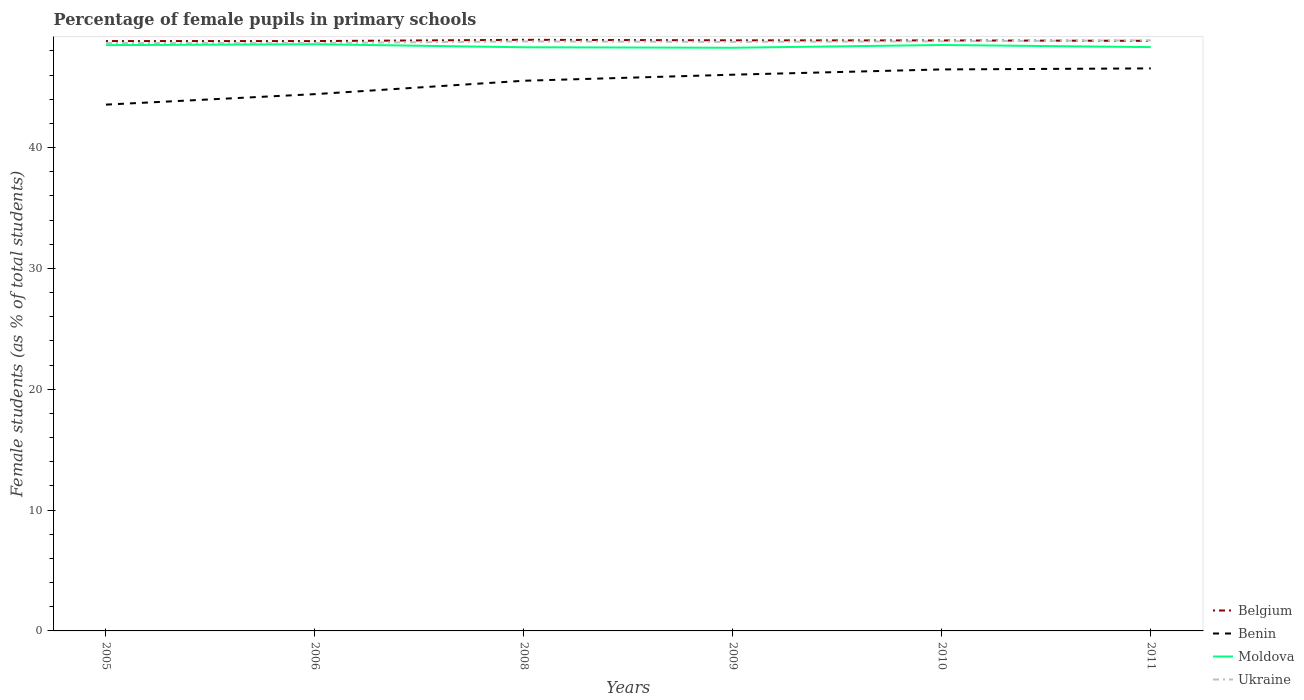Does the line corresponding to Ukraine intersect with the line corresponding to Benin?
Provide a short and direct response. No. Is the number of lines equal to the number of legend labels?
Make the answer very short. Yes. Across all years, what is the maximum percentage of female pupils in primary schools in Ukraine?
Provide a short and direct response. 48.65. In which year was the percentage of female pupils in primary schools in Ukraine maximum?
Offer a very short reply. 2005. What is the total percentage of female pupils in primary schools in Moldova in the graph?
Keep it short and to the point. -0.23. What is the difference between the highest and the second highest percentage of female pupils in primary schools in Moldova?
Offer a terse response. 0.29. What is the difference between the highest and the lowest percentage of female pupils in primary schools in Benin?
Give a very brief answer. 4. Is the percentage of female pupils in primary schools in Ukraine strictly greater than the percentage of female pupils in primary schools in Benin over the years?
Your response must be concise. No. How many lines are there?
Your response must be concise. 4. How many years are there in the graph?
Your response must be concise. 6. Does the graph contain grids?
Provide a succinct answer. No. What is the title of the graph?
Your answer should be very brief. Percentage of female pupils in primary schools. What is the label or title of the Y-axis?
Offer a terse response. Female students (as % of total students). What is the Female students (as % of total students) in Belgium in 2005?
Your answer should be very brief. 48.81. What is the Female students (as % of total students) of Benin in 2005?
Your answer should be compact. 43.55. What is the Female students (as % of total students) in Moldova in 2005?
Make the answer very short. 48.48. What is the Female students (as % of total students) of Ukraine in 2005?
Your answer should be compact. 48.65. What is the Female students (as % of total students) of Belgium in 2006?
Your answer should be very brief. 48.81. What is the Female students (as % of total students) in Benin in 2006?
Your answer should be compact. 44.42. What is the Female students (as % of total students) in Moldova in 2006?
Ensure brevity in your answer.  48.55. What is the Female students (as % of total students) of Ukraine in 2006?
Your answer should be compact. 48.65. What is the Female students (as % of total students) in Belgium in 2008?
Provide a succinct answer. 48.92. What is the Female students (as % of total students) of Benin in 2008?
Your answer should be very brief. 45.53. What is the Female students (as % of total students) of Moldova in 2008?
Keep it short and to the point. 48.3. What is the Female students (as % of total students) of Ukraine in 2008?
Keep it short and to the point. 48.79. What is the Female students (as % of total students) in Belgium in 2009?
Provide a succinct answer. 48.87. What is the Female students (as % of total students) of Benin in 2009?
Make the answer very short. 46.03. What is the Female students (as % of total students) of Moldova in 2009?
Provide a succinct answer. 48.26. What is the Female students (as % of total students) in Ukraine in 2009?
Keep it short and to the point. 48.75. What is the Female students (as % of total students) in Belgium in 2010?
Your answer should be compact. 48.86. What is the Female students (as % of total students) in Benin in 2010?
Provide a short and direct response. 46.47. What is the Female students (as % of total students) in Moldova in 2010?
Your response must be concise. 48.49. What is the Female students (as % of total students) of Ukraine in 2010?
Provide a succinct answer. 48.8. What is the Female students (as % of total students) of Belgium in 2011?
Offer a very short reply. 48.83. What is the Female students (as % of total students) of Benin in 2011?
Give a very brief answer. 46.55. What is the Female students (as % of total students) of Moldova in 2011?
Offer a terse response. 48.31. What is the Female students (as % of total students) in Ukraine in 2011?
Ensure brevity in your answer.  48.87. Across all years, what is the maximum Female students (as % of total students) in Belgium?
Make the answer very short. 48.92. Across all years, what is the maximum Female students (as % of total students) in Benin?
Offer a very short reply. 46.55. Across all years, what is the maximum Female students (as % of total students) of Moldova?
Offer a terse response. 48.55. Across all years, what is the maximum Female students (as % of total students) in Ukraine?
Give a very brief answer. 48.87. Across all years, what is the minimum Female students (as % of total students) of Belgium?
Your answer should be compact. 48.81. Across all years, what is the minimum Female students (as % of total students) in Benin?
Your answer should be compact. 43.55. Across all years, what is the minimum Female students (as % of total students) of Moldova?
Keep it short and to the point. 48.26. Across all years, what is the minimum Female students (as % of total students) in Ukraine?
Provide a short and direct response. 48.65. What is the total Female students (as % of total students) in Belgium in the graph?
Provide a succinct answer. 293.11. What is the total Female students (as % of total students) in Benin in the graph?
Provide a short and direct response. 272.55. What is the total Female students (as % of total students) of Moldova in the graph?
Give a very brief answer. 290.39. What is the total Female students (as % of total students) in Ukraine in the graph?
Make the answer very short. 292.5. What is the difference between the Female students (as % of total students) in Belgium in 2005 and that in 2006?
Your response must be concise. 0. What is the difference between the Female students (as % of total students) in Benin in 2005 and that in 2006?
Your answer should be compact. -0.87. What is the difference between the Female students (as % of total students) in Moldova in 2005 and that in 2006?
Offer a terse response. -0.08. What is the difference between the Female students (as % of total students) of Ukraine in 2005 and that in 2006?
Offer a terse response. -0. What is the difference between the Female students (as % of total students) in Belgium in 2005 and that in 2008?
Offer a terse response. -0.1. What is the difference between the Female students (as % of total students) in Benin in 2005 and that in 2008?
Provide a short and direct response. -1.98. What is the difference between the Female students (as % of total students) in Moldova in 2005 and that in 2008?
Provide a short and direct response. 0.18. What is the difference between the Female students (as % of total students) of Ukraine in 2005 and that in 2008?
Provide a succinct answer. -0.14. What is the difference between the Female students (as % of total students) in Belgium in 2005 and that in 2009?
Give a very brief answer. -0.06. What is the difference between the Female students (as % of total students) of Benin in 2005 and that in 2009?
Your response must be concise. -2.48. What is the difference between the Female students (as % of total students) in Moldova in 2005 and that in 2009?
Provide a short and direct response. 0.22. What is the difference between the Female students (as % of total students) of Ukraine in 2005 and that in 2009?
Your response must be concise. -0.1. What is the difference between the Female students (as % of total students) in Belgium in 2005 and that in 2010?
Offer a very short reply. -0.05. What is the difference between the Female students (as % of total students) in Benin in 2005 and that in 2010?
Offer a terse response. -2.91. What is the difference between the Female students (as % of total students) in Moldova in 2005 and that in 2010?
Provide a short and direct response. -0.01. What is the difference between the Female students (as % of total students) of Ukraine in 2005 and that in 2010?
Provide a short and direct response. -0.15. What is the difference between the Female students (as % of total students) in Belgium in 2005 and that in 2011?
Your answer should be very brief. -0.02. What is the difference between the Female students (as % of total students) of Benin in 2005 and that in 2011?
Offer a very short reply. -3. What is the difference between the Female students (as % of total students) of Moldova in 2005 and that in 2011?
Keep it short and to the point. 0.16. What is the difference between the Female students (as % of total students) of Ukraine in 2005 and that in 2011?
Give a very brief answer. -0.22. What is the difference between the Female students (as % of total students) in Belgium in 2006 and that in 2008?
Provide a short and direct response. -0.1. What is the difference between the Female students (as % of total students) of Benin in 2006 and that in 2008?
Offer a very short reply. -1.11. What is the difference between the Female students (as % of total students) in Moldova in 2006 and that in 2008?
Provide a succinct answer. 0.25. What is the difference between the Female students (as % of total students) in Ukraine in 2006 and that in 2008?
Provide a short and direct response. -0.14. What is the difference between the Female students (as % of total students) of Belgium in 2006 and that in 2009?
Your response must be concise. -0.06. What is the difference between the Female students (as % of total students) in Benin in 2006 and that in 2009?
Your answer should be compact. -1.61. What is the difference between the Female students (as % of total students) in Moldova in 2006 and that in 2009?
Provide a short and direct response. 0.29. What is the difference between the Female students (as % of total students) in Ukraine in 2006 and that in 2009?
Provide a short and direct response. -0.1. What is the difference between the Female students (as % of total students) in Belgium in 2006 and that in 2010?
Your answer should be compact. -0.05. What is the difference between the Female students (as % of total students) of Benin in 2006 and that in 2010?
Your answer should be compact. -2.05. What is the difference between the Female students (as % of total students) in Moldova in 2006 and that in 2010?
Provide a short and direct response. 0.06. What is the difference between the Female students (as % of total students) of Ukraine in 2006 and that in 2010?
Your answer should be compact. -0.15. What is the difference between the Female students (as % of total students) of Belgium in 2006 and that in 2011?
Ensure brevity in your answer.  -0.02. What is the difference between the Female students (as % of total students) in Benin in 2006 and that in 2011?
Ensure brevity in your answer.  -2.13. What is the difference between the Female students (as % of total students) of Moldova in 2006 and that in 2011?
Your answer should be very brief. 0.24. What is the difference between the Female students (as % of total students) of Ukraine in 2006 and that in 2011?
Give a very brief answer. -0.22. What is the difference between the Female students (as % of total students) of Belgium in 2008 and that in 2009?
Your answer should be very brief. 0.04. What is the difference between the Female students (as % of total students) of Benin in 2008 and that in 2009?
Ensure brevity in your answer.  -0.5. What is the difference between the Female students (as % of total students) in Moldova in 2008 and that in 2009?
Offer a very short reply. 0.04. What is the difference between the Female students (as % of total students) of Ukraine in 2008 and that in 2009?
Offer a terse response. 0.04. What is the difference between the Female students (as % of total students) in Belgium in 2008 and that in 2010?
Make the answer very short. 0.05. What is the difference between the Female students (as % of total students) in Benin in 2008 and that in 2010?
Ensure brevity in your answer.  -0.94. What is the difference between the Female students (as % of total students) of Moldova in 2008 and that in 2010?
Offer a very short reply. -0.19. What is the difference between the Female students (as % of total students) of Ukraine in 2008 and that in 2010?
Ensure brevity in your answer.  -0.01. What is the difference between the Female students (as % of total students) of Belgium in 2008 and that in 2011?
Offer a terse response. 0.08. What is the difference between the Female students (as % of total students) in Benin in 2008 and that in 2011?
Provide a short and direct response. -1.02. What is the difference between the Female students (as % of total students) in Moldova in 2008 and that in 2011?
Your answer should be compact. -0.01. What is the difference between the Female students (as % of total students) in Ukraine in 2008 and that in 2011?
Your answer should be very brief. -0.09. What is the difference between the Female students (as % of total students) of Belgium in 2009 and that in 2010?
Offer a very short reply. 0.01. What is the difference between the Female students (as % of total students) in Benin in 2009 and that in 2010?
Offer a terse response. -0.44. What is the difference between the Female students (as % of total students) in Moldova in 2009 and that in 2010?
Offer a terse response. -0.23. What is the difference between the Female students (as % of total students) in Ukraine in 2009 and that in 2010?
Provide a short and direct response. -0.05. What is the difference between the Female students (as % of total students) of Belgium in 2009 and that in 2011?
Offer a very short reply. 0.04. What is the difference between the Female students (as % of total students) of Benin in 2009 and that in 2011?
Give a very brief answer. -0.52. What is the difference between the Female students (as % of total students) in Moldova in 2009 and that in 2011?
Your answer should be compact. -0.05. What is the difference between the Female students (as % of total students) in Ukraine in 2009 and that in 2011?
Offer a terse response. -0.13. What is the difference between the Female students (as % of total students) in Belgium in 2010 and that in 2011?
Provide a short and direct response. 0.03. What is the difference between the Female students (as % of total students) in Benin in 2010 and that in 2011?
Give a very brief answer. -0.08. What is the difference between the Female students (as % of total students) of Moldova in 2010 and that in 2011?
Give a very brief answer. 0.17. What is the difference between the Female students (as % of total students) in Ukraine in 2010 and that in 2011?
Your response must be concise. -0.08. What is the difference between the Female students (as % of total students) in Belgium in 2005 and the Female students (as % of total students) in Benin in 2006?
Offer a terse response. 4.39. What is the difference between the Female students (as % of total students) of Belgium in 2005 and the Female students (as % of total students) of Moldova in 2006?
Provide a short and direct response. 0.26. What is the difference between the Female students (as % of total students) in Belgium in 2005 and the Female students (as % of total students) in Ukraine in 2006?
Offer a very short reply. 0.17. What is the difference between the Female students (as % of total students) in Benin in 2005 and the Female students (as % of total students) in Moldova in 2006?
Give a very brief answer. -5. What is the difference between the Female students (as % of total students) of Benin in 2005 and the Female students (as % of total students) of Ukraine in 2006?
Ensure brevity in your answer.  -5.1. What is the difference between the Female students (as % of total students) of Moldova in 2005 and the Female students (as % of total students) of Ukraine in 2006?
Your answer should be very brief. -0.17. What is the difference between the Female students (as % of total students) in Belgium in 2005 and the Female students (as % of total students) in Benin in 2008?
Ensure brevity in your answer.  3.29. What is the difference between the Female students (as % of total students) of Belgium in 2005 and the Female students (as % of total students) of Moldova in 2008?
Your answer should be compact. 0.52. What is the difference between the Female students (as % of total students) in Belgium in 2005 and the Female students (as % of total students) in Ukraine in 2008?
Your answer should be compact. 0.03. What is the difference between the Female students (as % of total students) in Benin in 2005 and the Female students (as % of total students) in Moldova in 2008?
Your answer should be compact. -4.74. What is the difference between the Female students (as % of total students) in Benin in 2005 and the Female students (as % of total students) in Ukraine in 2008?
Your response must be concise. -5.23. What is the difference between the Female students (as % of total students) of Moldova in 2005 and the Female students (as % of total students) of Ukraine in 2008?
Your response must be concise. -0.31. What is the difference between the Female students (as % of total students) in Belgium in 2005 and the Female students (as % of total students) in Benin in 2009?
Make the answer very short. 2.79. What is the difference between the Female students (as % of total students) of Belgium in 2005 and the Female students (as % of total students) of Moldova in 2009?
Your response must be concise. 0.55. What is the difference between the Female students (as % of total students) of Belgium in 2005 and the Female students (as % of total students) of Ukraine in 2009?
Ensure brevity in your answer.  0.07. What is the difference between the Female students (as % of total students) of Benin in 2005 and the Female students (as % of total students) of Moldova in 2009?
Offer a very short reply. -4.71. What is the difference between the Female students (as % of total students) in Benin in 2005 and the Female students (as % of total students) in Ukraine in 2009?
Keep it short and to the point. -5.19. What is the difference between the Female students (as % of total students) in Moldova in 2005 and the Female students (as % of total students) in Ukraine in 2009?
Give a very brief answer. -0.27. What is the difference between the Female students (as % of total students) in Belgium in 2005 and the Female students (as % of total students) in Benin in 2010?
Your answer should be very brief. 2.35. What is the difference between the Female students (as % of total students) in Belgium in 2005 and the Female students (as % of total students) in Moldova in 2010?
Ensure brevity in your answer.  0.33. What is the difference between the Female students (as % of total students) of Belgium in 2005 and the Female students (as % of total students) of Ukraine in 2010?
Your response must be concise. 0.02. What is the difference between the Female students (as % of total students) of Benin in 2005 and the Female students (as % of total students) of Moldova in 2010?
Ensure brevity in your answer.  -4.93. What is the difference between the Female students (as % of total students) of Benin in 2005 and the Female students (as % of total students) of Ukraine in 2010?
Offer a terse response. -5.24. What is the difference between the Female students (as % of total students) of Moldova in 2005 and the Female students (as % of total students) of Ukraine in 2010?
Give a very brief answer. -0.32. What is the difference between the Female students (as % of total students) of Belgium in 2005 and the Female students (as % of total students) of Benin in 2011?
Make the answer very short. 2.26. What is the difference between the Female students (as % of total students) of Belgium in 2005 and the Female students (as % of total students) of Moldova in 2011?
Your response must be concise. 0.5. What is the difference between the Female students (as % of total students) of Belgium in 2005 and the Female students (as % of total students) of Ukraine in 2011?
Your answer should be very brief. -0.06. What is the difference between the Female students (as % of total students) of Benin in 2005 and the Female students (as % of total students) of Moldova in 2011?
Provide a succinct answer. -4.76. What is the difference between the Female students (as % of total students) in Benin in 2005 and the Female students (as % of total students) in Ukraine in 2011?
Give a very brief answer. -5.32. What is the difference between the Female students (as % of total students) of Moldova in 2005 and the Female students (as % of total students) of Ukraine in 2011?
Your response must be concise. -0.4. What is the difference between the Female students (as % of total students) of Belgium in 2006 and the Female students (as % of total students) of Benin in 2008?
Offer a terse response. 3.28. What is the difference between the Female students (as % of total students) in Belgium in 2006 and the Female students (as % of total students) in Moldova in 2008?
Make the answer very short. 0.51. What is the difference between the Female students (as % of total students) of Belgium in 2006 and the Female students (as % of total students) of Ukraine in 2008?
Provide a short and direct response. 0.03. What is the difference between the Female students (as % of total students) in Benin in 2006 and the Female students (as % of total students) in Moldova in 2008?
Offer a very short reply. -3.88. What is the difference between the Female students (as % of total students) of Benin in 2006 and the Female students (as % of total students) of Ukraine in 2008?
Provide a short and direct response. -4.36. What is the difference between the Female students (as % of total students) in Moldova in 2006 and the Female students (as % of total students) in Ukraine in 2008?
Keep it short and to the point. -0.23. What is the difference between the Female students (as % of total students) in Belgium in 2006 and the Female students (as % of total students) in Benin in 2009?
Ensure brevity in your answer.  2.78. What is the difference between the Female students (as % of total students) of Belgium in 2006 and the Female students (as % of total students) of Moldova in 2009?
Ensure brevity in your answer.  0.55. What is the difference between the Female students (as % of total students) of Belgium in 2006 and the Female students (as % of total students) of Ukraine in 2009?
Provide a short and direct response. 0.07. What is the difference between the Female students (as % of total students) in Benin in 2006 and the Female students (as % of total students) in Moldova in 2009?
Your answer should be very brief. -3.84. What is the difference between the Female students (as % of total students) in Benin in 2006 and the Female students (as % of total students) in Ukraine in 2009?
Keep it short and to the point. -4.33. What is the difference between the Female students (as % of total students) of Moldova in 2006 and the Female students (as % of total students) of Ukraine in 2009?
Ensure brevity in your answer.  -0.19. What is the difference between the Female students (as % of total students) in Belgium in 2006 and the Female students (as % of total students) in Benin in 2010?
Your answer should be compact. 2.35. What is the difference between the Female students (as % of total students) in Belgium in 2006 and the Female students (as % of total students) in Moldova in 2010?
Keep it short and to the point. 0.32. What is the difference between the Female students (as % of total students) of Belgium in 2006 and the Female students (as % of total students) of Ukraine in 2010?
Make the answer very short. 0.02. What is the difference between the Female students (as % of total students) of Benin in 2006 and the Female students (as % of total students) of Moldova in 2010?
Keep it short and to the point. -4.07. What is the difference between the Female students (as % of total students) in Benin in 2006 and the Female students (as % of total students) in Ukraine in 2010?
Your answer should be very brief. -4.37. What is the difference between the Female students (as % of total students) in Moldova in 2006 and the Female students (as % of total students) in Ukraine in 2010?
Your response must be concise. -0.24. What is the difference between the Female students (as % of total students) of Belgium in 2006 and the Female students (as % of total students) of Benin in 2011?
Provide a short and direct response. 2.26. What is the difference between the Female students (as % of total students) in Belgium in 2006 and the Female students (as % of total students) in Moldova in 2011?
Offer a very short reply. 0.5. What is the difference between the Female students (as % of total students) of Belgium in 2006 and the Female students (as % of total students) of Ukraine in 2011?
Offer a terse response. -0.06. What is the difference between the Female students (as % of total students) of Benin in 2006 and the Female students (as % of total students) of Moldova in 2011?
Make the answer very short. -3.89. What is the difference between the Female students (as % of total students) in Benin in 2006 and the Female students (as % of total students) in Ukraine in 2011?
Ensure brevity in your answer.  -4.45. What is the difference between the Female students (as % of total students) in Moldova in 2006 and the Female students (as % of total students) in Ukraine in 2011?
Make the answer very short. -0.32. What is the difference between the Female students (as % of total students) in Belgium in 2008 and the Female students (as % of total students) in Benin in 2009?
Give a very brief answer. 2.89. What is the difference between the Female students (as % of total students) of Belgium in 2008 and the Female students (as % of total students) of Moldova in 2009?
Your answer should be compact. 0.66. What is the difference between the Female students (as % of total students) in Belgium in 2008 and the Female students (as % of total students) in Ukraine in 2009?
Make the answer very short. 0.17. What is the difference between the Female students (as % of total students) of Benin in 2008 and the Female students (as % of total students) of Moldova in 2009?
Your answer should be very brief. -2.73. What is the difference between the Female students (as % of total students) in Benin in 2008 and the Female students (as % of total students) in Ukraine in 2009?
Your response must be concise. -3.22. What is the difference between the Female students (as % of total students) of Moldova in 2008 and the Female students (as % of total students) of Ukraine in 2009?
Ensure brevity in your answer.  -0.45. What is the difference between the Female students (as % of total students) in Belgium in 2008 and the Female students (as % of total students) in Benin in 2010?
Provide a short and direct response. 2.45. What is the difference between the Female students (as % of total students) of Belgium in 2008 and the Female students (as % of total students) of Moldova in 2010?
Keep it short and to the point. 0.43. What is the difference between the Female students (as % of total students) of Belgium in 2008 and the Female students (as % of total students) of Ukraine in 2010?
Give a very brief answer. 0.12. What is the difference between the Female students (as % of total students) in Benin in 2008 and the Female students (as % of total students) in Moldova in 2010?
Your answer should be compact. -2.96. What is the difference between the Female students (as % of total students) in Benin in 2008 and the Female students (as % of total students) in Ukraine in 2010?
Provide a short and direct response. -3.27. What is the difference between the Female students (as % of total students) in Moldova in 2008 and the Female students (as % of total students) in Ukraine in 2010?
Offer a terse response. -0.5. What is the difference between the Female students (as % of total students) of Belgium in 2008 and the Female students (as % of total students) of Benin in 2011?
Keep it short and to the point. 2.37. What is the difference between the Female students (as % of total students) in Belgium in 2008 and the Female students (as % of total students) in Moldova in 2011?
Keep it short and to the point. 0.6. What is the difference between the Female students (as % of total students) in Belgium in 2008 and the Female students (as % of total students) in Ukraine in 2011?
Offer a terse response. 0.04. What is the difference between the Female students (as % of total students) of Benin in 2008 and the Female students (as % of total students) of Moldova in 2011?
Your answer should be very brief. -2.78. What is the difference between the Female students (as % of total students) in Benin in 2008 and the Female students (as % of total students) in Ukraine in 2011?
Your answer should be compact. -3.34. What is the difference between the Female students (as % of total students) of Moldova in 2008 and the Female students (as % of total students) of Ukraine in 2011?
Provide a short and direct response. -0.57. What is the difference between the Female students (as % of total students) of Belgium in 2009 and the Female students (as % of total students) of Benin in 2010?
Make the answer very short. 2.41. What is the difference between the Female students (as % of total students) in Belgium in 2009 and the Female students (as % of total students) in Moldova in 2010?
Provide a succinct answer. 0.39. What is the difference between the Female students (as % of total students) of Belgium in 2009 and the Female students (as % of total students) of Ukraine in 2010?
Make the answer very short. 0.08. What is the difference between the Female students (as % of total students) in Benin in 2009 and the Female students (as % of total students) in Moldova in 2010?
Ensure brevity in your answer.  -2.46. What is the difference between the Female students (as % of total students) in Benin in 2009 and the Female students (as % of total students) in Ukraine in 2010?
Provide a succinct answer. -2.77. What is the difference between the Female students (as % of total students) in Moldova in 2009 and the Female students (as % of total students) in Ukraine in 2010?
Your answer should be compact. -0.54. What is the difference between the Female students (as % of total students) of Belgium in 2009 and the Female students (as % of total students) of Benin in 2011?
Your answer should be compact. 2.32. What is the difference between the Female students (as % of total students) in Belgium in 2009 and the Female students (as % of total students) in Moldova in 2011?
Provide a succinct answer. 0.56. What is the difference between the Female students (as % of total students) of Belgium in 2009 and the Female students (as % of total students) of Ukraine in 2011?
Provide a short and direct response. 0. What is the difference between the Female students (as % of total students) of Benin in 2009 and the Female students (as % of total students) of Moldova in 2011?
Make the answer very short. -2.28. What is the difference between the Female students (as % of total students) of Benin in 2009 and the Female students (as % of total students) of Ukraine in 2011?
Your response must be concise. -2.84. What is the difference between the Female students (as % of total students) of Moldova in 2009 and the Female students (as % of total students) of Ukraine in 2011?
Offer a terse response. -0.61. What is the difference between the Female students (as % of total students) in Belgium in 2010 and the Female students (as % of total students) in Benin in 2011?
Your answer should be compact. 2.31. What is the difference between the Female students (as % of total students) of Belgium in 2010 and the Female students (as % of total students) of Moldova in 2011?
Keep it short and to the point. 0.55. What is the difference between the Female students (as % of total students) of Belgium in 2010 and the Female students (as % of total students) of Ukraine in 2011?
Ensure brevity in your answer.  -0.01. What is the difference between the Female students (as % of total students) of Benin in 2010 and the Female students (as % of total students) of Moldova in 2011?
Provide a succinct answer. -1.85. What is the difference between the Female students (as % of total students) in Benin in 2010 and the Female students (as % of total students) in Ukraine in 2011?
Give a very brief answer. -2.41. What is the difference between the Female students (as % of total students) of Moldova in 2010 and the Female students (as % of total students) of Ukraine in 2011?
Offer a terse response. -0.38. What is the average Female students (as % of total students) of Belgium per year?
Your answer should be compact. 48.85. What is the average Female students (as % of total students) of Benin per year?
Offer a very short reply. 45.42. What is the average Female students (as % of total students) of Moldova per year?
Make the answer very short. 48.4. What is the average Female students (as % of total students) in Ukraine per year?
Keep it short and to the point. 48.75. In the year 2005, what is the difference between the Female students (as % of total students) in Belgium and Female students (as % of total students) in Benin?
Ensure brevity in your answer.  5.26. In the year 2005, what is the difference between the Female students (as % of total students) in Belgium and Female students (as % of total students) in Moldova?
Keep it short and to the point. 0.34. In the year 2005, what is the difference between the Female students (as % of total students) of Belgium and Female students (as % of total students) of Ukraine?
Offer a terse response. 0.17. In the year 2005, what is the difference between the Female students (as % of total students) of Benin and Female students (as % of total students) of Moldova?
Your response must be concise. -4.92. In the year 2005, what is the difference between the Female students (as % of total students) of Benin and Female students (as % of total students) of Ukraine?
Ensure brevity in your answer.  -5.09. In the year 2005, what is the difference between the Female students (as % of total students) in Moldova and Female students (as % of total students) in Ukraine?
Give a very brief answer. -0.17. In the year 2006, what is the difference between the Female students (as % of total students) in Belgium and Female students (as % of total students) in Benin?
Offer a terse response. 4.39. In the year 2006, what is the difference between the Female students (as % of total students) in Belgium and Female students (as % of total students) in Moldova?
Offer a terse response. 0.26. In the year 2006, what is the difference between the Female students (as % of total students) in Belgium and Female students (as % of total students) in Ukraine?
Provide a succinct answer. 0.16. In the year 2006, what is the difference between the Female students (as % of total students) in Benin and Female students (as % of total students) in Moldova?
Provide a succinct answer. -4.13. In the year 2006, what is the difference between the Female students (as % of total students) in Benin and Female students (as % of total students) in Ukraine?
Offer a very short reply. -4.23. In the year 2006, what is the difference between the Female students (as % of total students) in Moldova and Female students (as % of total students) in Ukraine?
Provide a short and direct response. -0.1. In the year 2008, what is the difference between the Female students (as % of total students) in Belgium and Female students (as % of total students) in Benin?
Offer a terse response. 3.39. In the year 2008, what is the difference between the Female students (as % of total students) in Belgium and Female students (as % of total students) in Moldova?
Your answer should be compact. 0.62. In the year 2008, what is the difference between the Female students (as % of total students) of Belgium and Female students (as % of total students) of Ukraine?
Provide a succinct answer. 0.13. In the year 2008, what is the difference between the Female students (as % of total students) in Benin and Female students (as % of total students) in Moldova?
Give a very brief answer. -2.77. In the year 2008, what is the difference between the Female students (as % of total students) of Benin and Female students (as % of total students) of Ukraine?
Provide a short and direct response. -3.26. In the year 2008, what is the difference between the Female students (as % of total students) of Moldova and Female students (as % of total students) of Ukraine?
Keep it short and to the point. -0.49. In the year 2009, what is the difference between the Female students (as % of total students) of Belgium and Female students (as % of total students) of Benin?
Ensure brevity in your answer.  2.84. In the year 2009, what is the difference between the Female students (as % of total students) in Belgium and Female students (as % of total students) in Moldova?
Give a very brief answer. 0.61. In the year 2009, what is the difference between the Female students (as % of total students) of Belgium and Female students (as % of total students) of Ukraine?
Ensure brevity in your answer.  0.13. In the year 2009, what is the difference between the Female students (as % of total students) of Benin and Female students (as % of total students) of Moldova?
Ensure brevity in your answer.  -2.23. In the year 2009, what is the difference between the Female students (as % of total students) of Benin and Female students (as % of total students) of Ukraine?
Provide a short and direct response. -2.72. In the year 2009, what is the difference between the Female students (as % of total students) in Moldova and Female students (as % of total students) in Ukraine?
Offer a terse response. -0.49. In the year 2010, what is the difference between the Female students (as % of total students) of Belgium and Female students (as % of total students) of Benin?
Provide a short and direct response. 2.4. In the year 2010, what is the difference between the Female students (as % of total students) in Belgium and Female students (as % of total students) in Moldova?
Make the answer very short. 0.38. In the year 2010, what is the difference between the Female students (as % of total students) in Belgium and Female students (as % of total students) in Ukraine?
Make the answer very short. 0.07. In the year 2010, what is the difference between the Female students (as % of total students) in Benin and Female students (as % of total students) in Moldova?
Provide a short and direct response. -2.02. In the year 2010, what is the difference between the Female students (as % of total students) in Benin and Female students (as % of total students) in Ukraine?
Give a very brief answer. -2.33. In the year 2010, what is the difference between the Female students (as % of total students) of Moldova and Female students (as % of total students) of Ukraine?
Ensure brevity in your answer.  -0.31. In the year 2011, what is the difference between the Female students (as % of total students) of Belgium and Female students (as % of total students) of Benin?
Offer a terse response. 2.28. In the year 2011, what is the difference between the Female students (as % of total students) of Belgium and Female students (as % of total students) of Moldova?
Provide a succinct answer. 0.52. In the year 2011, what is the difference between the Female students (as % of total students) of Belgium and Female students (as % of total students) of Ukraine?
Keep it short and to the point. -0.04. In the year 2011, what is the difference between the Female students (as % of total students) in Benin and Female students (as % of total students) in Moldova?
Offer a very short reply. -1.76. In the year 2011, what is the difference between the Female students (as % of total students) in Benin and Female students (as % of total students) in Ukraine?
Keep it short and to the point. -2.32. In the year 2011, what is the difference between the Female students (as % of total students) of Moldova and Female students (as % of total students) of Ukraine?
Ensure brevity in your answer.  -0.56. What is the ratio of the Female students (as % of total students) in Belgium in 2005 to that in 2006?
Your answer should be very brief. 1. What is the ratio of the Female students (as % of total students) in Benin in 2005 to that in 2006?
Provide a short and direct response. 0.98. What is the ratio of the Female students (as % of total students) of Moldova in 2005 to that in 2006?
Your response must be concise. 1. What is the ratio of the Female students (as % of total students) in Benin in 2005 to that in 2008?
Make the answer very short. 0.96. What is the ratio of the Female students (as % of total students) in Moldova in 2005 to that in 2008?
Your answer should be compact. 1. What is the ratio of the Female students (as % of total students) in Benin in 2005 to that in 2009?
Offer a very short reply. 0.95. What is the ratio of the Female students (as % of total students) of Moldova in 2005 to that in 2009?
Offer a very short reply. 1. What is the ratio of the Female students (as % of total students) of Ukraine in 2005 to that in 2009?
Your response must be concise. 1. What is the ratio of the Female students (as % of total students) in Benin in 2005 to that in 2010?
Your answer should be compact. 0.94. What is the ratio of the Female students (as % of total students) of Ukraine in 2005 to that in 2010?
Provide a short and direct response. 1. What is the ratio of the Female students (as % of total students) in Benin in 2005 to that in 2011?
Offer a terse response. 0.94. What is the ratio of the Female students (as % of total students) in Ukraine in 2005 to that in 2011?
Provide a short and direct response. 1. What is the ratio of the Female students (as % of total students) in Benin in 2006 to that in 2008?
Your answer should be compact. 0.98. What is the ratio of the Female students (as % of total students) in Ukraine in 2006 to that in 2008?
Provide a succinct answer. 1. What is the ratio of the Female students (as % of total students) of Moldova in 2006 to that in 2009?
Offer a very short reply. 1.01. What is the ratio of the Female students (as % of total students) of Benin in 2006 to that in 2010?
Keep it short and to the point. 0.96. What is the ratio of the Female students (as % of total students) in Benin in 2006 to that in 2011?
Keep it short and to the point. 0.95. What is the ratio of the Female students (as % of total students) of Ukraine in 2008 to that in 2009?
Ensure brevity in your answer.  1. What is the ratio of the Female students (as % of total students) of Benin in 2008 to that in 2010?
Give a very brief answer. 0.98. What is the ratio of the Female students (as % of total students) of Moldova in 2008 to that in 2010?
Provide a short and direct response. 1. What is the ratio of the Female students (as % of total students) in Benin in 2009 to that in 2010?
Give a very brief answer. 0.99. What is the ratio of the Female students (as % of total students) in Moldova in 2009 to that in 2010?
Ensure brevity in your answer.  1. What is the ratio of the Female students (as % of total students) of Moldova in 2009 to that in 2011?
Your answer should be very brief. 1. What is the ratio of the Female students (as % of total students) of Benin in 2010 to that in 2011?
Your response must be concise. 1. What is the difference between the highest and the second highest Female students (as % of total students) of Belgium?
Ensure brevity in your answer.  0.04. What is the difference between the highest and the second highest Female students (as % of total students) in Benin?
Your response must be concise. 0.08. What is the difference between the highest and the second highest Female students (as % of total students) of Moldova?
Make the answer very short. 0.06. What is the difference between the highest and the second highest Female students (as % of total students) of Ukraine?
Ensure brevity in your answer.  0.08. What is the difference between the highest and the lowest Female students (as % of total students) of Belgium?
Offer a very short reply. 0.1. What is the difference between the highest and the lowest Female students (as % of total students) in Benin?
Your answer should be compact. 3. What is the difference between the highest and the lowest Female students (as % of total students) in Moldova?
Keep it short and to the point. 0.29. What is the difference between the highest and the lowest Female students (as % of total students) in Ukraine?
Keep it short and to the point. 0.22. 